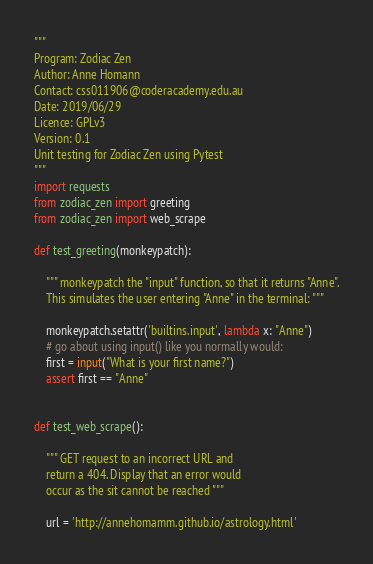<code> <loc_0><loc_0><loc_500><loc_500><_Python_>"""
Program: Zodiac Zen
Author: Anne Homann
Contact: css011906@coderacademy.edu.au
Date: 2019/06/29
Licence: GPLv3
Version: 0.1
Unit testing for Zodiac Zen using Pytest
"""
import requests
from zodiac_zen import greeting
from zodiac_zen import web_scrape

def test_greeting(monkeypatch):

    """ monkeypatch the "input" function, so that it returns "Anne".
    This simulates the user entering "Anne" in the terminal: """

    monkeypatch.setattr('builtins.input', lambda x: "Anne")
    # go about using input() like you normally would:
    first = input("What is your first name?")
    assert first == "Anne"


def test_web_scrape():

    """ GET request to an incorrect URL and
    return a 404. Display that an error would
    occur as the sit cannot be reached """

    url = 'http://annehomamm.github.io/astrology.html'</code> 